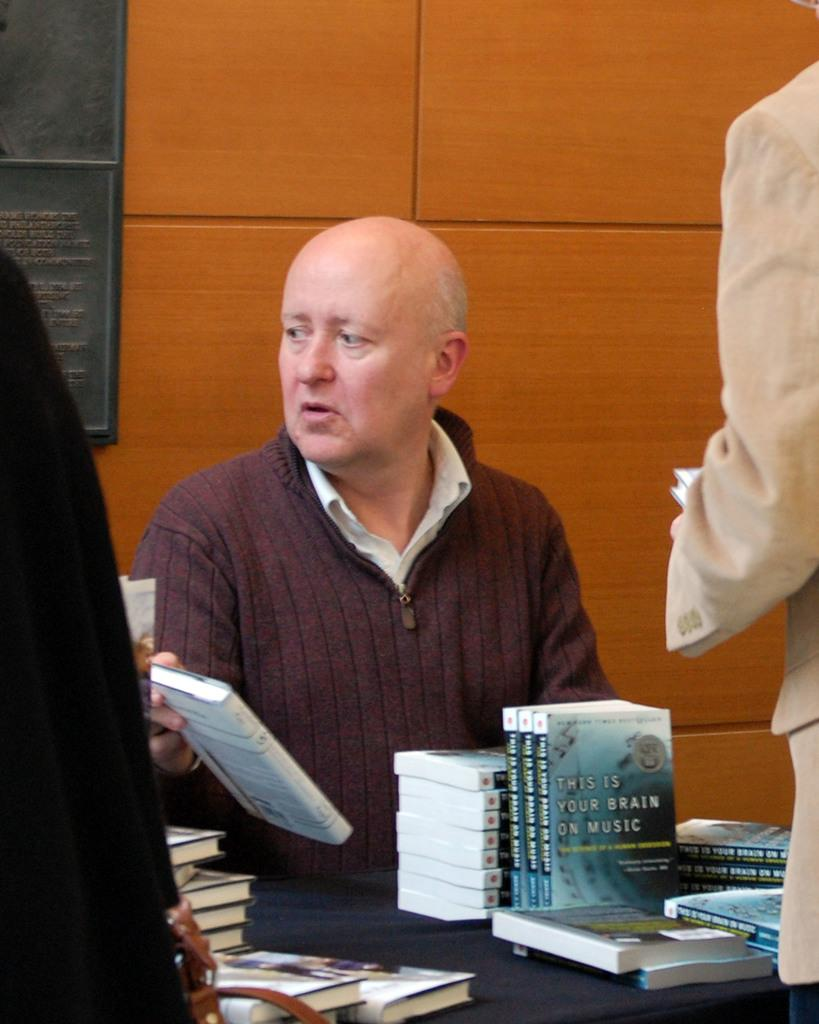<image>
Describe the image concisely. a man next to a book with the word brain on it 